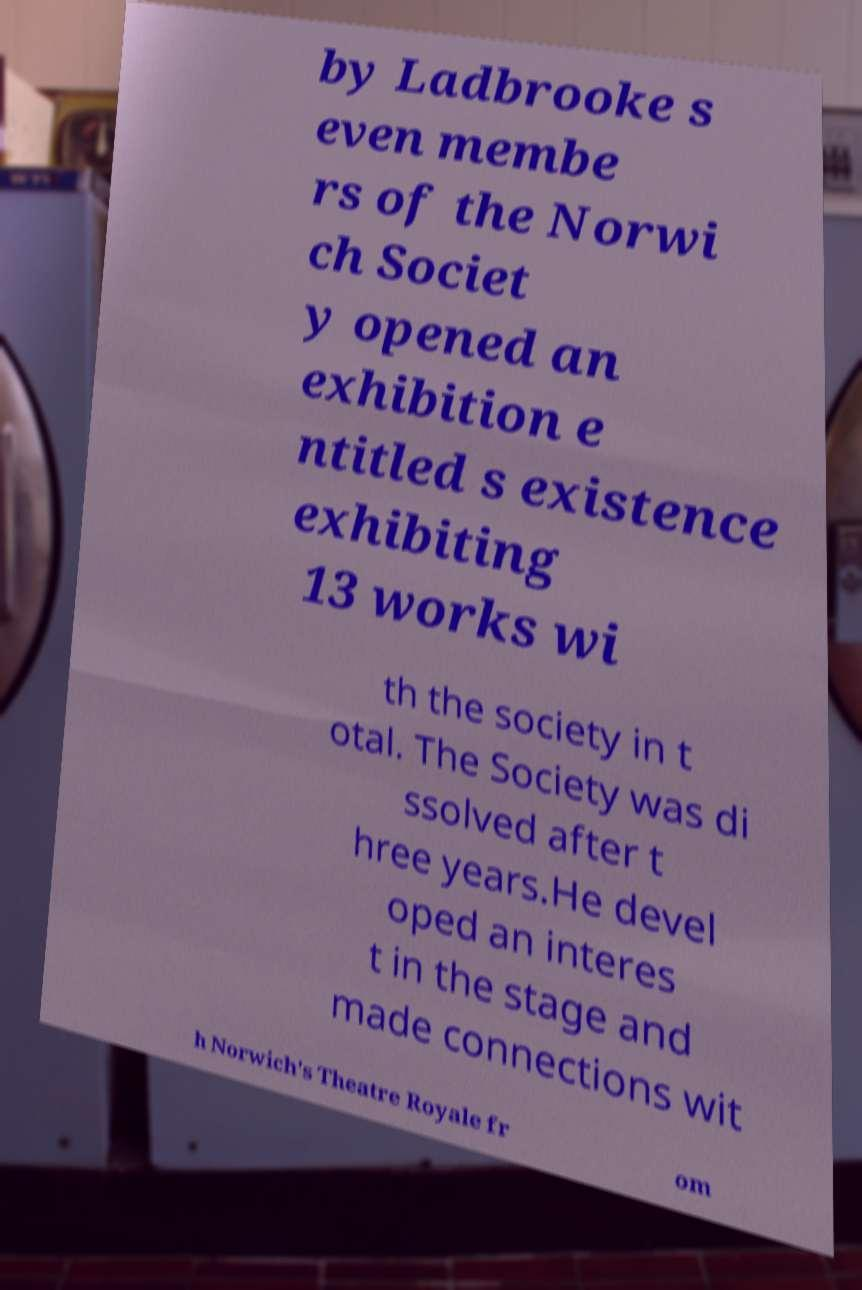I need the written content from this picture converted into text. Can you do that? by Ladbrooke s even membe rs of the Norwi ch Societ y opened an exhibition e ntitled s existence exhibiting 13 works wi th the society in t otal. The Society was di ssolved after t hree years.He devel oped an interes t in the stage and made connections wit h Norwich's Theatre Royale fr om 